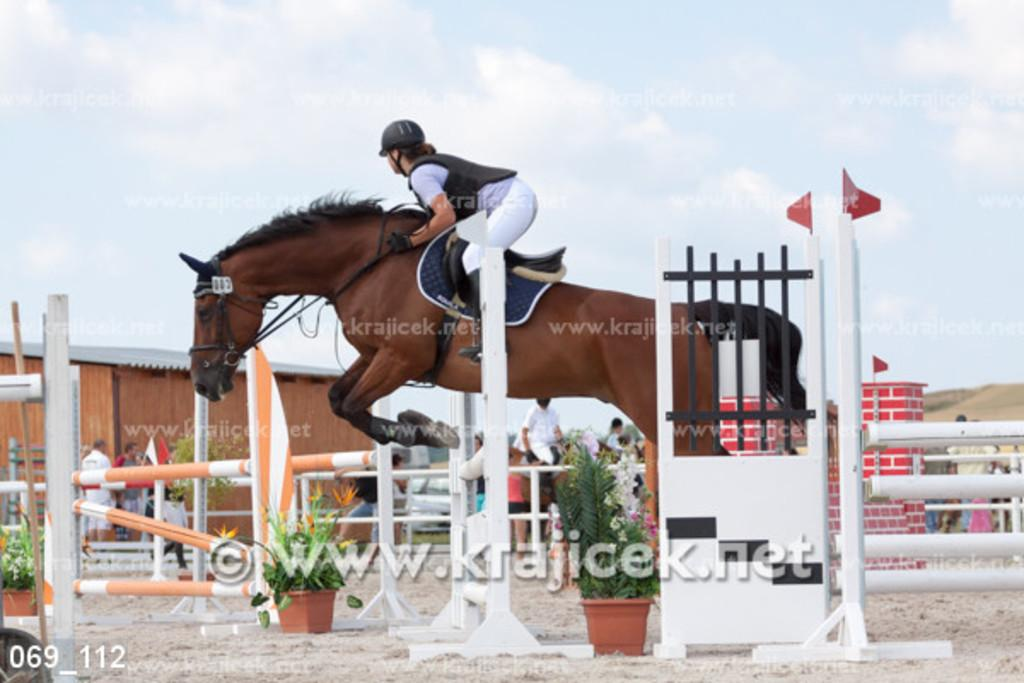What is the main activity happening in the image? There is a person riding a horse in the image. What type of objects can be seen in the image besides the horse and rider? There are potted plants, poles, people, flags, a vehicle, and a shed in the image. What is visible in the background of the image? The sky is visible in the background of the image. What type of drum can be heard playing in the image? There is no drum present in the image, and therefore no sound can be heard. 